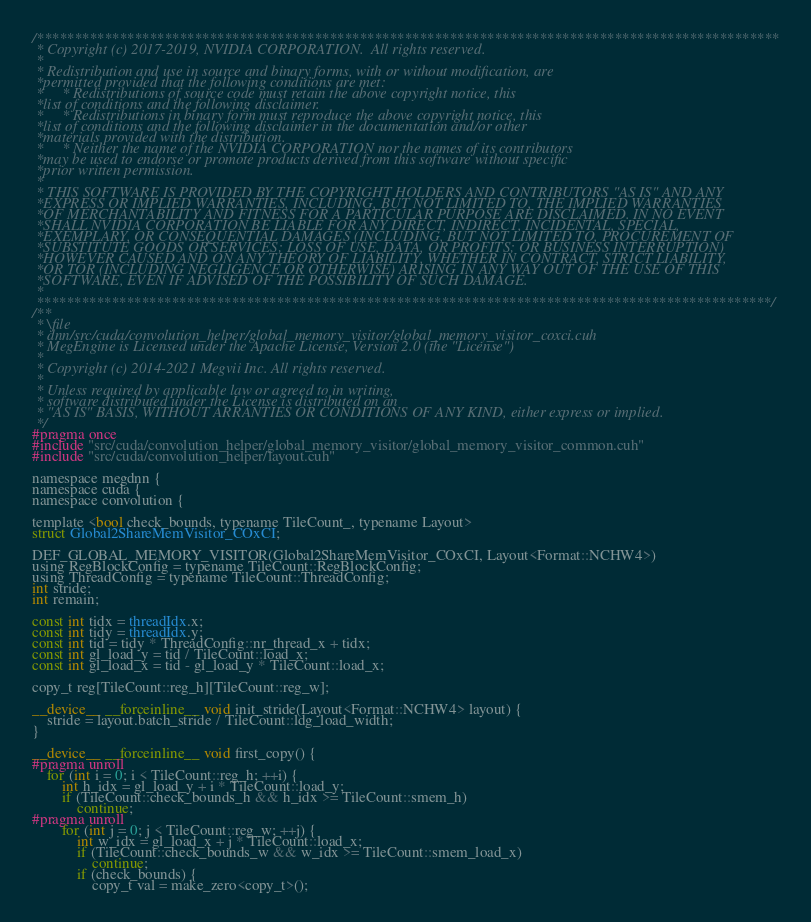Convert code to text. <code><loc_0><loc_0><loc_500><loc_500><_Cuda_>/***************************************************************************************************
 * Copyright (c) 2017-2019, NVIDIA CORPORATION.  All rights reserved.
 *
 * Redistribution and use in source and binary forms, with or without modification, are
 *permitted provided that the following conditions are met:
 *     * Redistributions of source code must retain the above copyright notice, this
 *list of conditions and the following disclaimer.
 *     * Redistributions in binary form must reproduce the above copyright notice, this
 *list of conditions and the following disclaimer in the documentation and/or other
 *materials provided with the distribution.
 *     * Neither the name of the NVIDIA CORPORATION nor the names of its contributors
 *may be used to endorse or promote products derived from this software without specific
 *prior written permission.
 *
 * THIS SOFTWARE IS PROVIDED BY THE COPYRIGHT HOLDERS AND CONTRIBUTORS "AS IS" AND ANY
 *EXPRESS OR IMPLIED WARRANTIES, INCLUDING, BUT NOT LIMITED TO, THE IMPLIED WARRANTIES
 *OF MERCHANTABILITY AND FITNESS FOR A PARTICULAR PURPOSE ARE DISCLAIMED. IN NO EVENT
 *SHALL NVIDIA CORPORATION BE LIABLE FOR ANY DIRECT, INDIRECT, INCIDENTAL, SPECIAL,
 *EXEMPLARY, OR CONSEQUENTIAL DAMAGES (INCLUDING, BUT NOT LIMITED TO, PROCUREMENT OF
 *SUBSTITUTE GOODS OR SERVICES; LOSS OF USE, DATA, OR PROFITS; OR BUSINESS INTERRUPTION)
 *HOWEVER CAUSED AND ON ANY THEORY OF LIABILITY, WHETHER IN CONTRACT, STRICT LIABILITY,
 *OR TOR (INCLUDING NEGLIGENCE OR OTHERWISE) ARISING IN ANY WAY OUT OF THE USE OF THIS
 *SOFTWARE, EVEN IF ADVISED OF THE POSSIBILITY OF SUCH DAMAGE.
 *
 **************************************************************************************************/
/**
 * \file
 * dnn/src/cuda/convolution_helper/global_memory_visitor/global_memory_visitor_coxci.cuh
 * MegEngine is Licensed under the Apache License, Version 2.0 (the "License")
 *
 * Copyright (c) 2014-2021 Megvii Inc. All rights reserved.
 *
 * Unless required by applicable law or agreed to in writing,
 * software distributed under the License is distributed on an
 * "AS IS" BASIS, WITHOUT ARRANTIES OR CONDITIONS OF ANY KIND, either express or implied.
 */
#pragma once
#include "src/cuda/convolution_helper/global_memory_visitor/global_memory_visitor_common.cuh"
#include "src/cuda/convolution_helper/layout.cuh"

namespace megdnn {
namespace cuda {
namespace convolution {

template <bool check_bounds, typename TileCount_, typename Layout>
struct Global2ShareMemVisitor_COxCI;

DEF_GLOBAL_MEMORY_VISITOR(Global2ShareMemVisitor_COxCI, Layout<Format::NCHW4>)
using RegBlockConfig = typename TileCount::RegBlockConfig;
using ThreadConfig = typename TileCount::ThreadConfig;
int stride;
int remain;

const int tidx = threadIdx.x;
const int tidy = threadIdx.y;
const int tid = tidy * ThreadConfig::nr_thread_x + tidx;
const int gl_load_y = tid / TileCount::load_x;
const int gl_load_x = tid - gl_load_y * TileCount::load_x;

copy_t reg[TileCount::reg_h][TileCount::reg_w];

__device__ __forceinline__ void init_stride(Layout<Format::NCHW4> layout) {
    stride = layout.batch_stride / TileCount::ldg_load_width;
}

__device__ __forceinline__ void first_copy() {
#pragma unroll
    for (int i = 0; i < TileCount::reg_h; ++i) {
        int h_idx = gl_load_y + i * TileCount::load_y;
        if (TileCount::check_bounds_h && h_idx >= TileCount::smem_h)
            continue;
#pragma unroll
        for (int j = 0; j < TileCount::reg_w; ++j) {
            int w_idx = gl_load_x + j * TileCount::load_x;
            if (TileCount::check_bounds_w && w_idx >= TileCount::smem_load_x)
                continue;
            if (check_bounds) {
                copy_t val = make_zero<copy_t>();</code> 